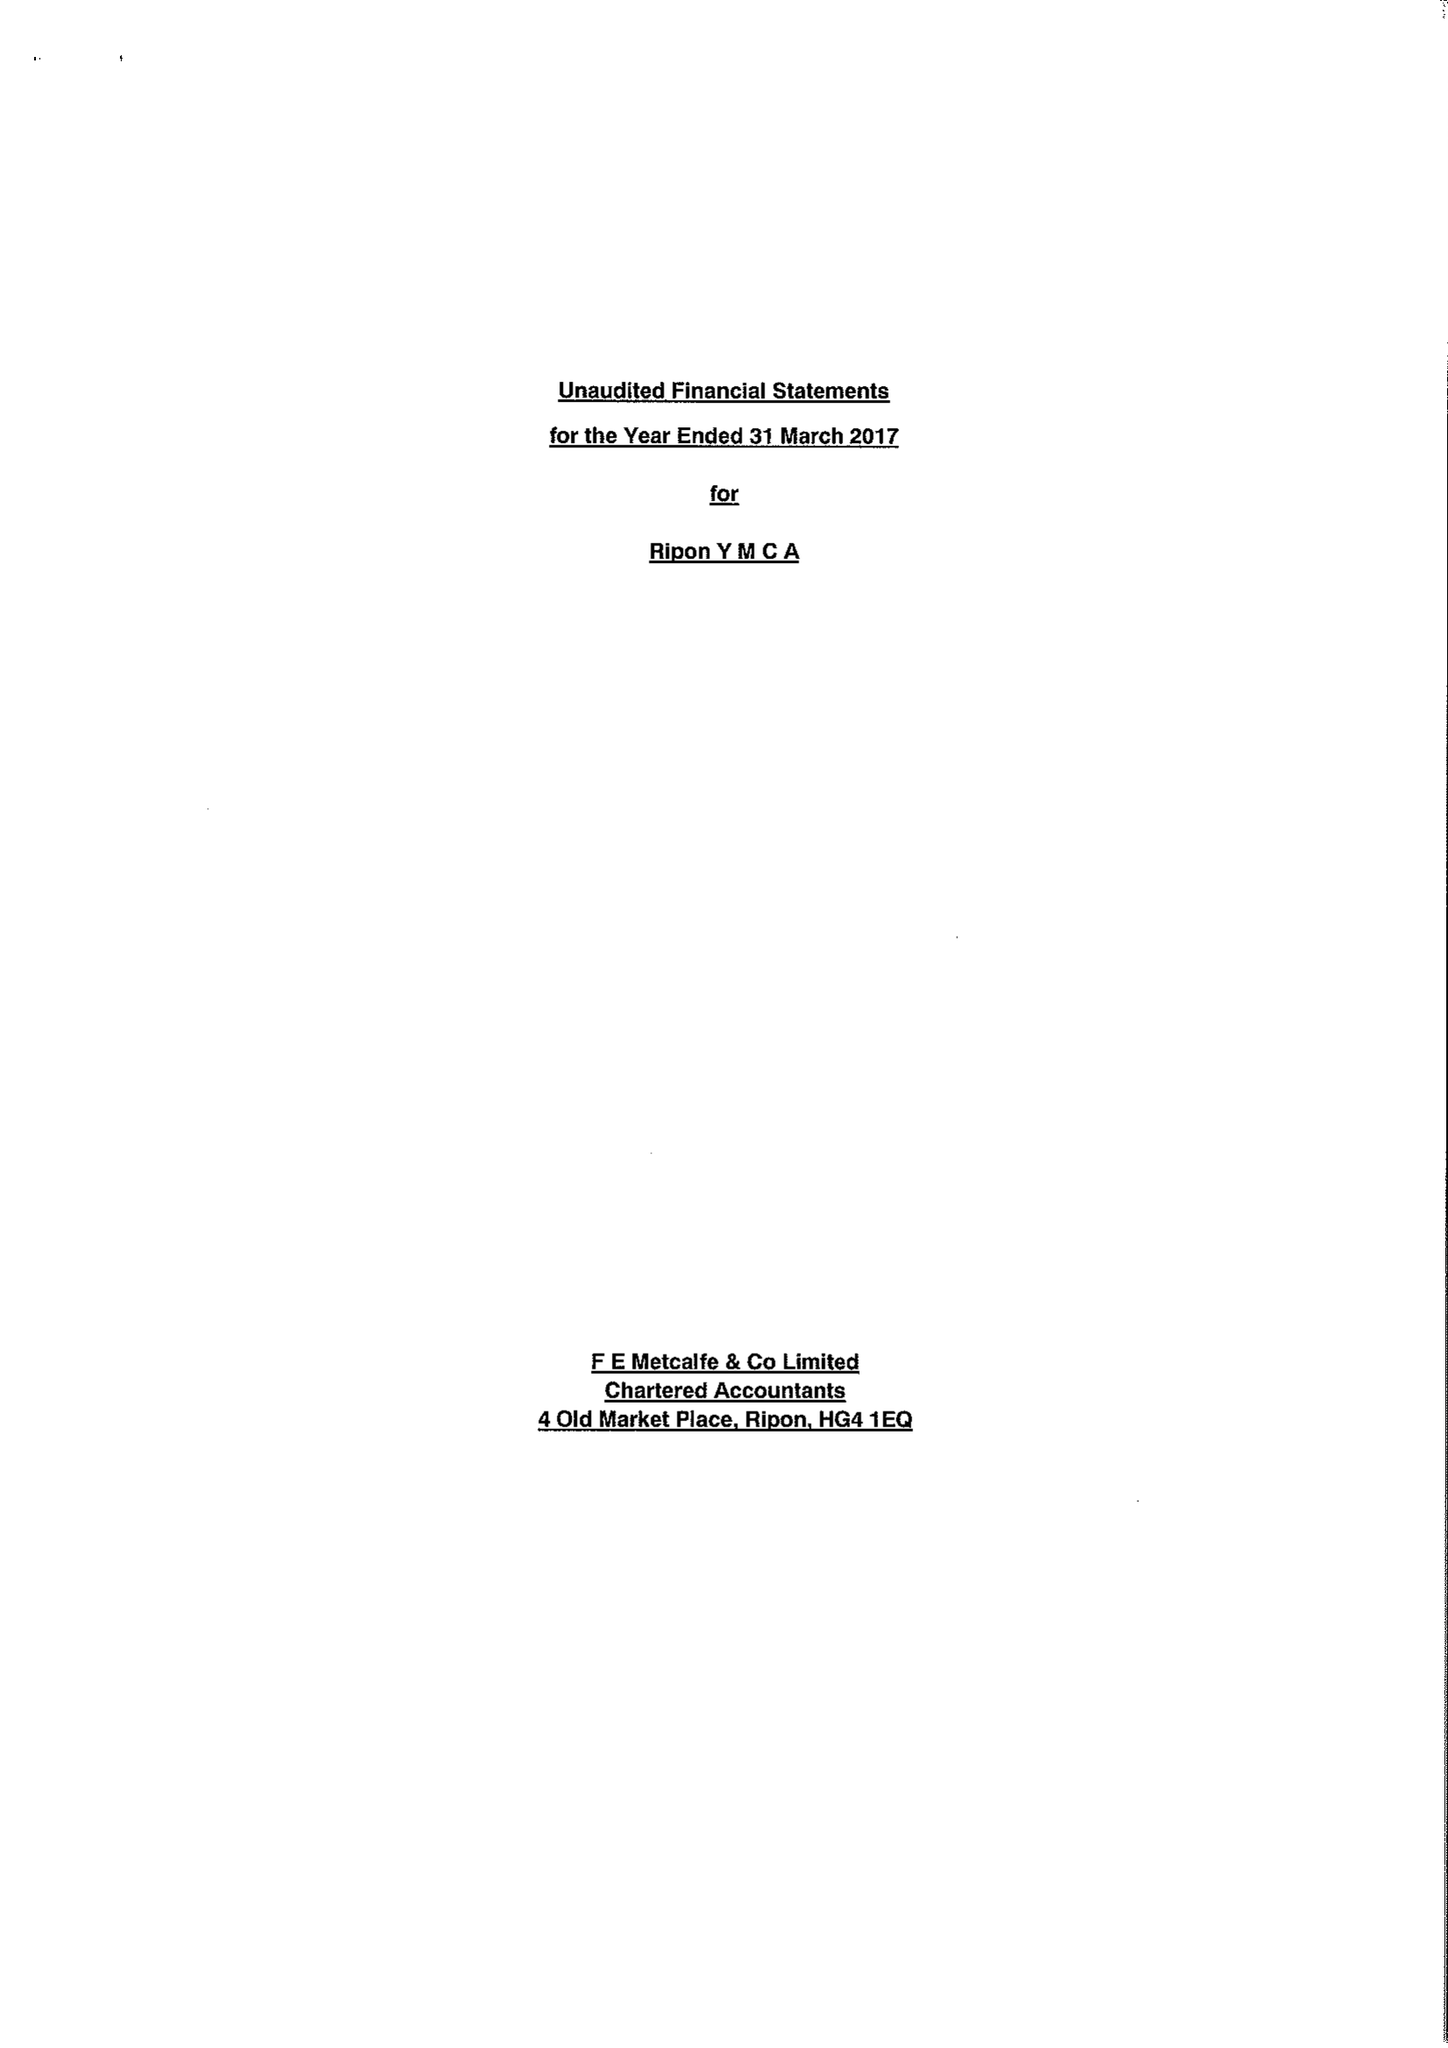What is the value for the report_date?
Answer the question using a single word or phrase. 2017-03-31 